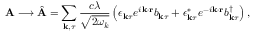<formula> <loc_0><loc_0><loc_500><loc_500>A \longrightarrow \hat { A } = \sum _ { k , \tau } \frac { c \lambda } { \sqrt { 2 \omega _ { k } } } \left ( \epsilon _ { k \tau } e ^ { i k \cdot r } b _ { k \tau } + \epsilon _ { k \tau } ^ { * } e ^ { - i k \cdot r } b _ { k \tau } ^ { \dagger } \right ) ,</formula> 